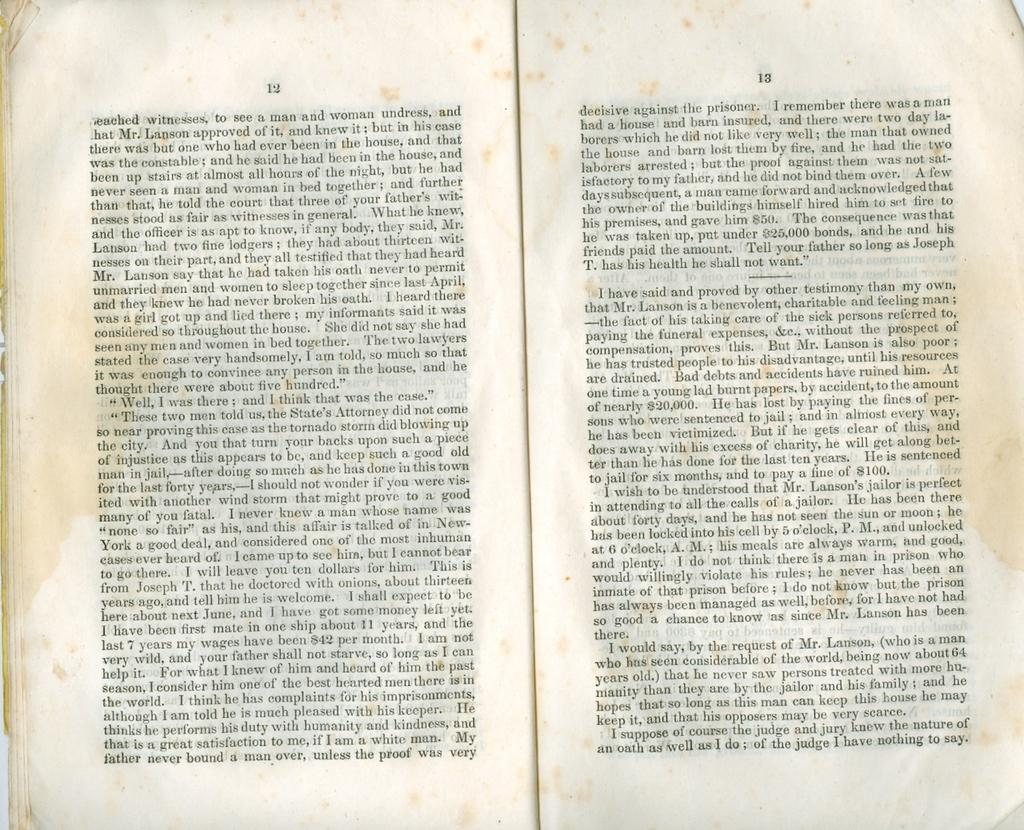<image>
Provide a brief description of the given image. A book open to pages 12 and 13 and a few stained pages. 